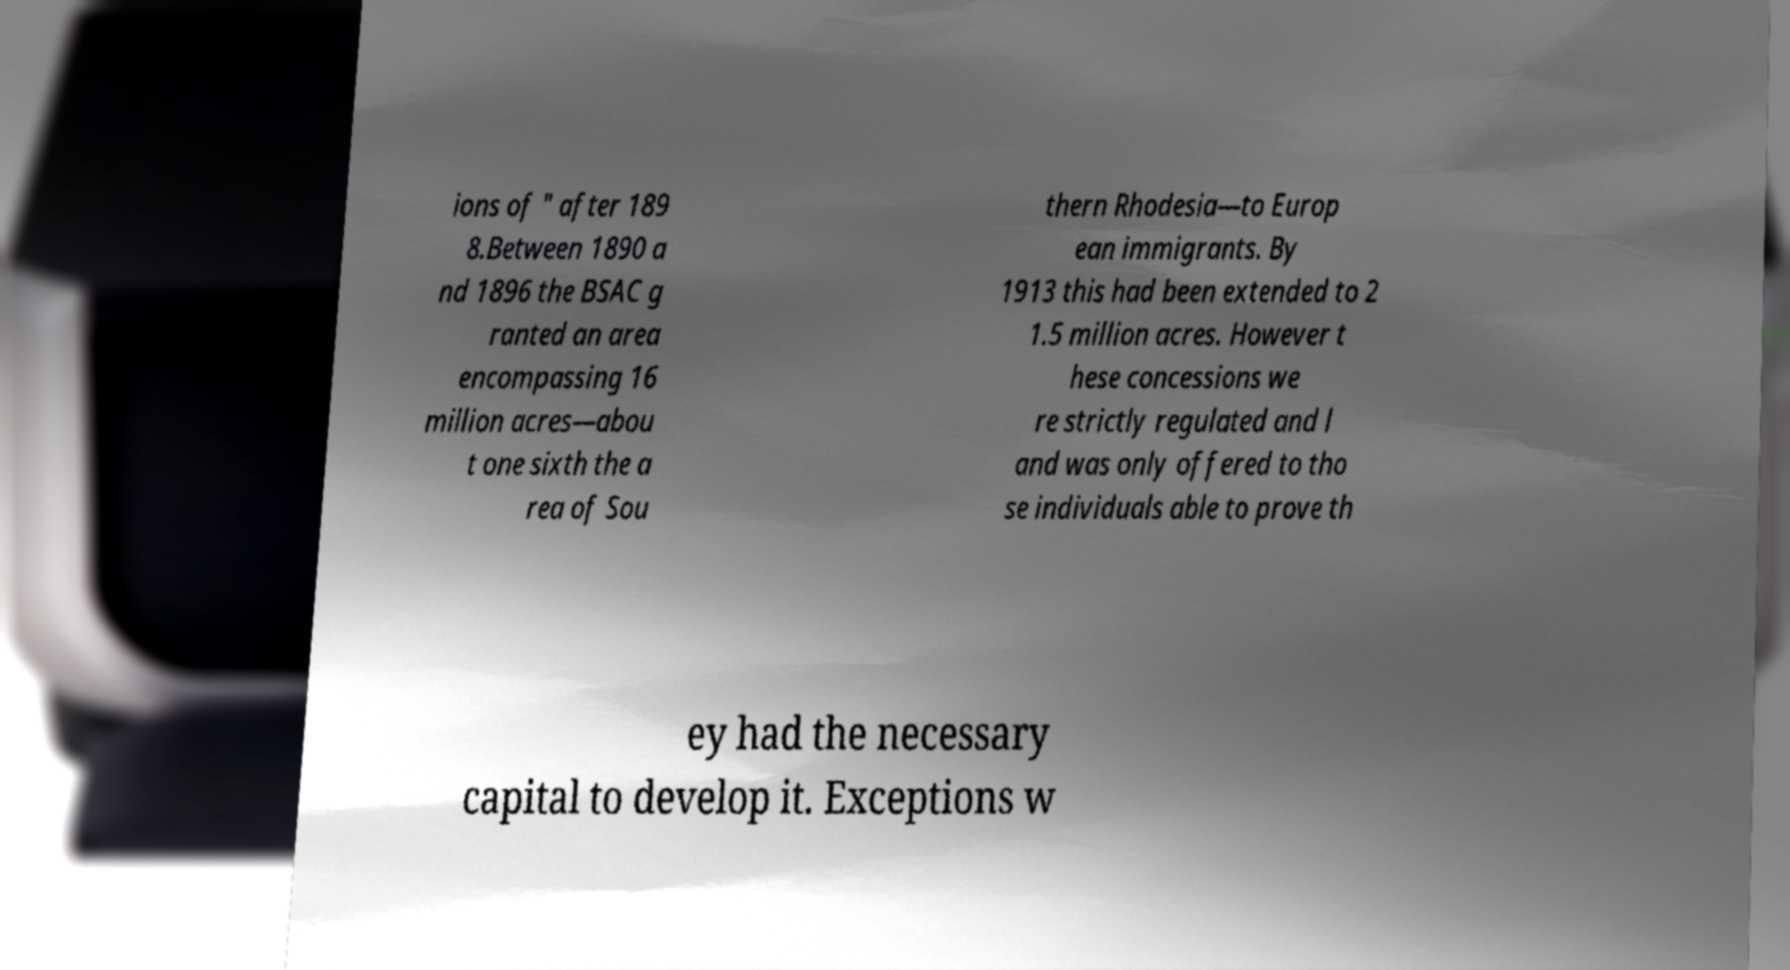I need the written content from this picture converted into text. Can you do that? ions of " after 189 8.Between 1890 a nd 1896 the BSAC g ranted an area encompassing 16 million acres—abou t one sixth the a rea of Sou thern Rhodesia—to Europ ean immigrants. By 1913 this had been extended to 2 1.5 million acres. However t hese concessions we re strictly regulated and l and was only offered to tho se individuals able to prove th ey had the necessary capital to develop it. Exceptions w 